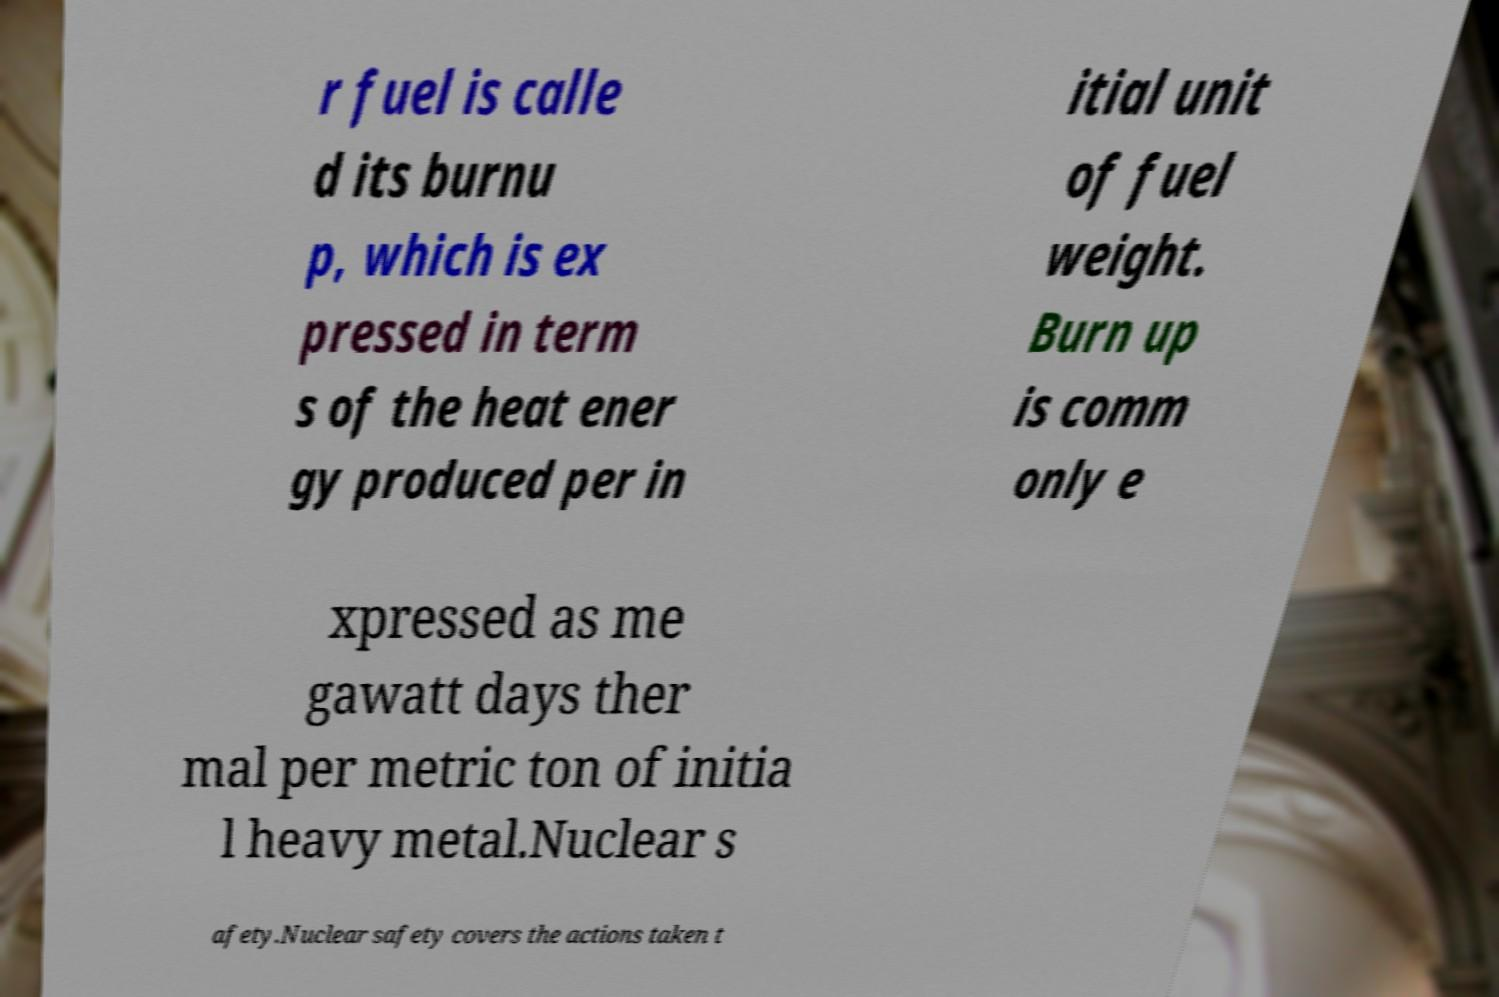There's text embedded in this image that I need extracted. Can you transcribe it verbatim? r fuel is calle d its burnu p, which is ex pressed in term s of the heat ener gy produced per in itial unit of fuel weight. Burn up is comm only e xpressed as me gawatt days ther mal per metric ton of initia l heavy metal.Nuclear s afety.Nuclear safety covers the actions taken t 